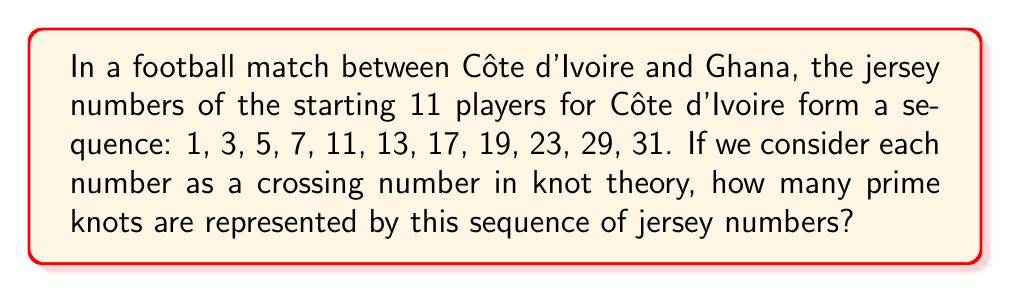Show me your answer to this math problem. To solve this problem, we need to follow these steps:

1) In knot theory, prime knots are knots that cannot be decomposed into simpler knots. The number of crossings in a knot diagram is related to its complexity.

2) The sequence of jersey numbers given is: 1, 3, 5, 7, 11, 13, 17, 19, 23, 29, 31.

3) In knot theory, knots are classified by their crossing number. The smallest non-trivial knot is the trefoil knot, which has 3 crossings.

4) Let's analyze each number:

   - 1: Not a valid knot (it would be an unknot)
   - 3: Represents the trefoil knot, which is prime
   - 5: Represents the cinquefoil knot, which is prime
   - 7: Represents the septfoil knot, which is prime
   - 11: Represents a prime knot (there is only one 11-crossing prime knot)
   - 13: Represents a prime knot (there are several 13-crossing prime knots)
   - 17: Represents a prime knot
   - 19: Represents a prime knot
   - 23: Represents a prime knot
   - 29: Represents a prime knot
   - 31: Represents a prime knot

5) Counting the prime knots, we get a total of 10 prime knots represented in this sequence.
Answer: 10 